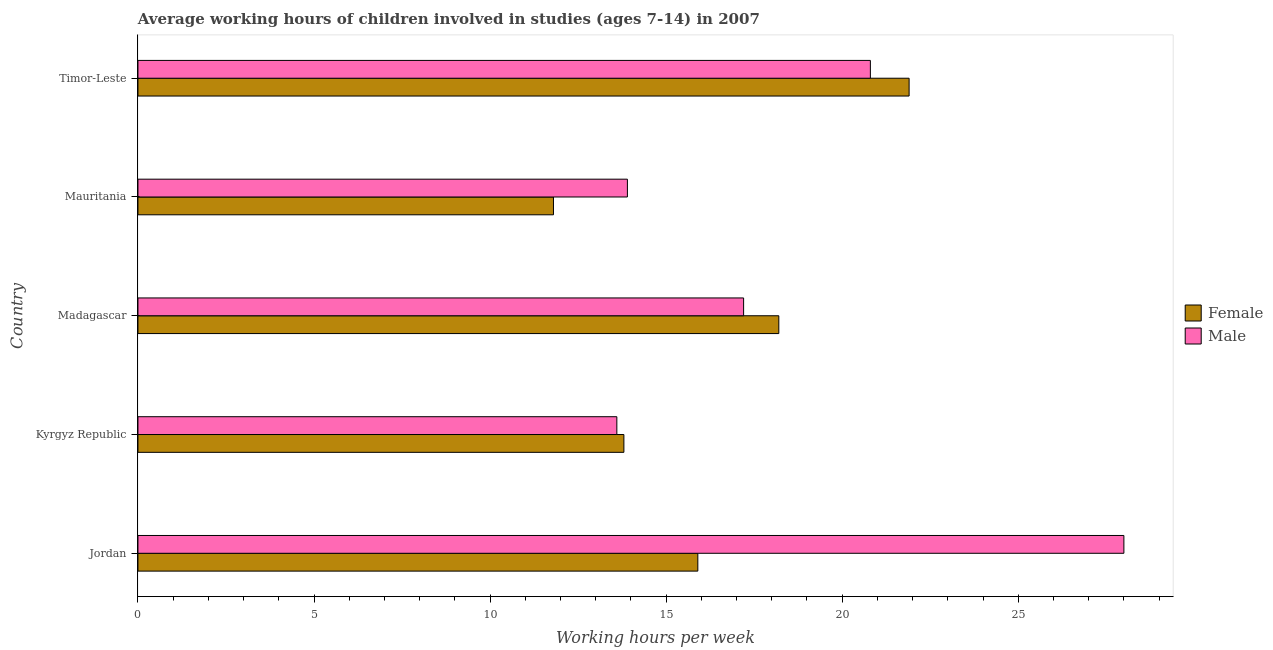How many bars are there on the 3rd tick from the top?
Offer a very short reply. 2. How many bars are there on the 1st tick from the bottom?
Offer a very short reply. 2. What is the label of the 1st group of bars from the top?
Your response must be concise. Timor-Leste. In how many cases, is the number of bars for a given country not equal to the number of legend labels?
Offer a terse response. 0. What is the average working hour of male children in Timor-Leste?
Offer a terse response. 20.8. Across all countries, what is the maximum average working hour of male children?
Offer a terse response. 28. Across all countries, what is the minimum average working hour of male children?
Offer a very short reply. 13.6. In which country was the average working hour of female children maximum?
Provide a short and direct response. Timor-Leste. In which country was the average working hour of male children minimum?
Keep it short and to the point. Kyrgyz Republic. What is the total average working hour of male children in the graph?
Your response must be concise. 93.5. What is the difference between the average working hour of female children in Madagascar and that in Timor-Leste?
Your response must be concise. -3.7. What is the difference between the average working hour of male children in Kyrgyz Republic and the average working hour of female children in Mauritania?
Offer a terse response. 1.8. What is the average average working hour of female children per country?
Your answer should be very brief. 16.32. What is the difference between the average working hour of female children and average working hour of male children in Mauritania?
Provide a short and direct response. -2.1. In how many countries, is the average working hour of male children greater than 14 hours?
Provide a short and direct response. 3. What is the ratio of the average working hour of male children in Mauritania to that in Timor-Leste?
Provide a succinct answer. 0.67. Is the average working hour of female children in Kyrgyz Republic less than that in Timor-Leste?
Give a very brief answer. Yes. Is the difference between the average working hour of male children in Madagascar and Timor-Leste greater than the difference between the average working hour of female children in Madagascar and Timor-Leste?
Give a very brief answer. Yes. What is the difference between the highest and the second highest average working hour of female children?
Offer a very short reply. 3.7. In how many countries, is the average working hour of male children greater than the average average working hour of male children taken over all countries?
Make the answer very short. 2. What does the 1st bar from the bottom in Madagascar represents?
Your response must be concise. Female. Are all the bars in the graph horizontal?
Ensure brevity in your answer.  Yes. What is the difference between two consecutive major ticks on the X-axis?
Provide a succinct answer. 5. Are the values on the major ticks of X-axis written in scientific E-notation?
Your response must be concise. No. Does the graph contain any zero values?
Give a very brief answer. No. Does the graph contain grids?
Give a very brief answer. No. What is the title of the graph?
Your answer should be very brief. Average working hours of children involved in studies (ages 7-14) in 2007. Does "Quasi money growth" appear as one of the legend labels in the graph?
Ensure brevity in your answer.  No. What is the label or title of the X-axis?
Give a very brief answer. Working hours per week. What is the Working hours per week of Female in Madagascar?
Make the answer very short. 18.2. What is the Working hours per week in Female in Mauritania?
Make the answer very short. 11.8. What is the Working hours per week of Female in Timor-Leste?
Your response must be concise. 21.9. What is the Working hours per week in Male in Timor-Leste?
Ensure brevity in your answer.  20.8. Across all countries, what is the maximum Working hours per week in Female?
Offer a very short reply. 21.9. Across all countries, what is the maximum Working hours per week in Male?
Offer a terse response. 28. What is the total Working hours per week of Female in the graph?
Ensure brevity in your answer.  81.6. What is the total Working hours per week in Male in the graph?
Keep it short and to the point. 93.5. What is the difference between the Working hours per week of Female in Jordan and that in Madagascar?
Your answer should be compact. -2.3. What is the difference between the Working hours per week in Male in Jordan and that in Madagascar?
Ensure brevity in your answer.  10.8. What is the difference between the Working hours per week of Female in Jordan and that in Mauritania?
Ensure brevity in your answer.  4.1. What is the difference between the Working hours per week in Male in Jordan and that in Mauritania?
Offer a terse response. 14.1. What is the difference between the Working hours per week in Female in Kyrgyz Republic and that in Madagascar?
Give a very brief answer. -4.4. What is the difference between the Working hours per week in Male in Kyrgyz Republic and that in Mauritania?
Make the answer very short. -0.3. What is the difference between the Working hours per week of Female in Kyrgyz Republic and that in Timor-Leste?
Your answer should be very brief. -8.1. What is the difference between the Working hours per week in Female in Madagascar and that in Mauritania?
Provide a short and direct response. 6.4. What is the difference between the Working hours per week in Male in Madagascar and that in Mauritania?
Keep it short and to the point. 3.3. What is the difference between the Working hours per week of Male in Madagascar and that in Timor-Leste?
Make the answer very short. -3.6. What is the difference between the Working hours per week in Male in Mauritania and that in Timor-Leste?
Your answer should be compact. -6.9. What is the difference between the Working hours per week in Female in Jordan and the Working hours per week in Male in Madagascar?
Your answer should be very brief. -1.3. What is the difference between the Working hours per week of Female in Kyrgyz Republic and the Working hours per week of Male in Timor-Leste?
Provide a short and direct response. -7. What is the difference between the Working hours per week in Female in Mauritania and the Working hours per week in Male in Timor-Leste?
Your response must be concise. -9. What is the average Working hours per week in Female per country?
Provide a succinct answer. 16.32. What is the difference between the Working hours per week in Female and Working hours per week in Male in Jordan?
Keep it short and to the point. -12.1. What is the difference between the Working hours per week in Female and Working hours per week in Male in Madagascar?
Keep it short and to the point. 1. What is the difference between the Working hours per week of Female and Working hours per week of Male in Mauritania?
Your answer should be very brief. -2.1. What is the difference between the Working hours per week in Female and Working hours per week in Male in Timor-Leste?
Keep it short and to the point. 1.1. What is the ratio of the Working hours per week in Female in Jordan to that in Kyrgyz Republic?
Ensure brevity in your answer.  1.15. What is the ratio of the Working hours per week of Male in Jordan to that in Kyrgyz Republic?
Your answer should be compact. 2.06. What is the ratio of the Working hours per week in Female in Jordan to that in Madagascar?
Keep it short and to the point. 0.87. What is the ratio of the Working hours per week in Male in Jordan to that in Madagascar?
Your response must be concise. 1.63. What is the ratio of the Working hours per week of Female in Jordan to that in Mauritania?
Give a very brief answer. 1.35. What is the ratio of the Working hours per week of Male in Jordan to that in Mauritania?
Offer a very short reply. 2.01. What is the ratio of the Working hours per week in Female in Jordan to that in Timor-Leste?
Offer a terse response. 0.73. What is the ratio of the Working hours per week of Male in Jordan to that in Timor-Leste?
Your answer should be compact. 1.35. What is the ratio of the Working hours per week of Female in Kyrgyz Republic to that in Madagascar?
Your answer should be very brief. 0.76. What is the ratio of the Working hours per week of Male in Kyrgyz Republic to that in Madagascar?
Give a very brief answer. 0.79. What is the ratio of the Working hours per week in Female in Kyrgyz Republic to that in Mauritania?
Provide a short and direct response. 1.17. What is the ratio of the Working hours per week in Male in Kyrgyz Republic to that in Mauritania?
Your response must be concise. 0.98. What is the ratio of the Working hours per week in Female in Kyrgyz Republic to that in Timor-Leste?
Make the answer very short. 0.63. What is the ratio of the Working hours per week of Male in Kyrgyz Republic to that in Timor-Leste?
Offer a very short reply. 0.65. What is the ratio of the Working hours per week of Female in Madagascar to that in Mauritania?
Give a very brief answer. 1.54. What is the ratio of the Working hours per week in Male in Madagascar to that in Mauritania?
Provide a short and direct response. 1.24. What is the ratio of the Working hours per week of Female in Madagascar to that in Timor-Leste?
Your answer should be very brief. 0.83. What is the ratio of the Working hours per week in Male in Madagascar to that in Timor-Leste?
Your answer should be very brief. 0.83. What is the ratio of the Working hours per week of Female in Mauritania to that in Timor-Leste?
Provide a succinct answer. 0.54. What is the ratio of the Working hours per week of Male in Mauritania to that in Timor-Leste?
Offer a very short reply. 0.67. What is the difference between the highest and the second highest Working hours per week of Female?
Your answer should be very brief. 3.7. What is the difference between the highest and the lowest Working hours per week of Female?
Make the answer very short. 10.1. 